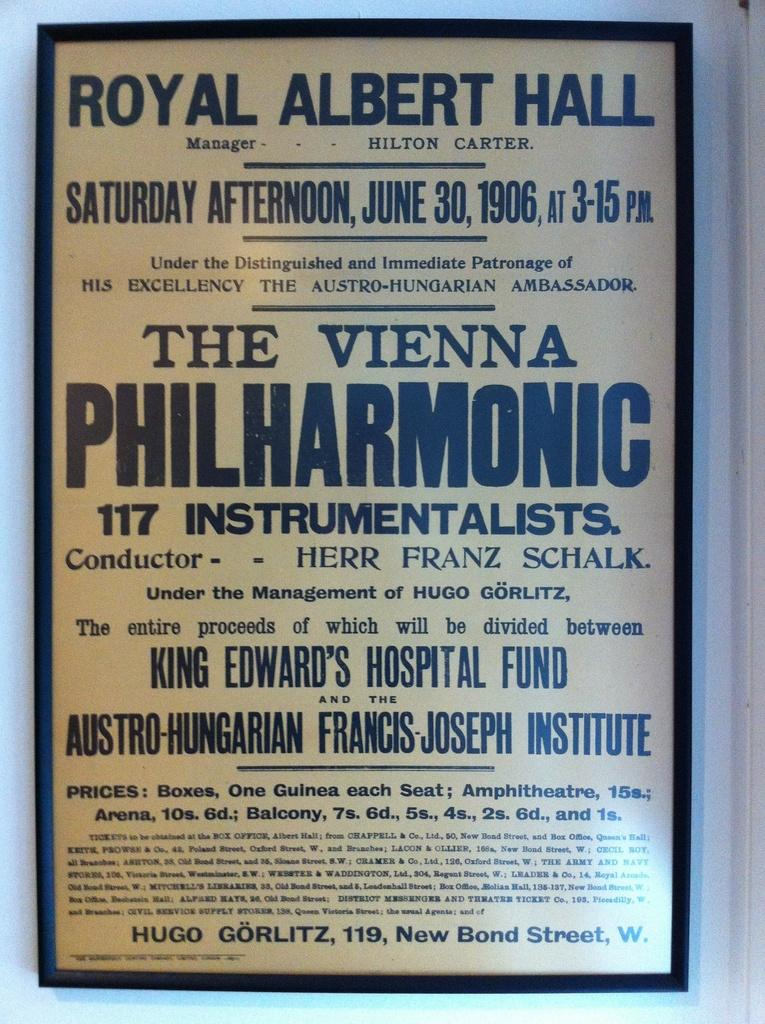Provide a one-sentence caption for the provided image. A sign that has many words with PHILHARMONIC being the largest. 